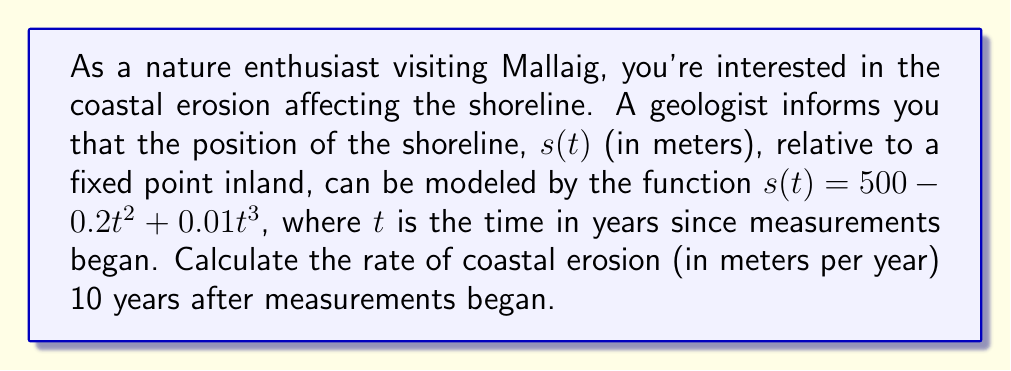Could you help me with this problem? To find the rate of coastal erosion at a specific time, we need to calculate the derivative of the shoreline position function and evaluate it at the given time.

1) The shoreline position function is:
   $s(t) = 500 - 0.2t^2 + 0.01t^3$

2) To find the rate of change, we need to find $s'(t)$:
   $s'(t) = -0.4t + 0.03t^2$

3) The rate of erosion is the negative of this value (since erosion decreases the distance from the fixed point):
   Rate of erosion = $-s'(t) = 0.4t - 0.03t^2$

4) We want to evaluate this at $t = 10$ years:
   Rate of erosion at 10 years = $0.4(10) - 0.03(10)^2$
                                = $4 - 3$
                                = $1$

Therefore, the rate of coastal erosion 10 years after measurements began is 1 meter per year.
Answer: 1 meter per year 